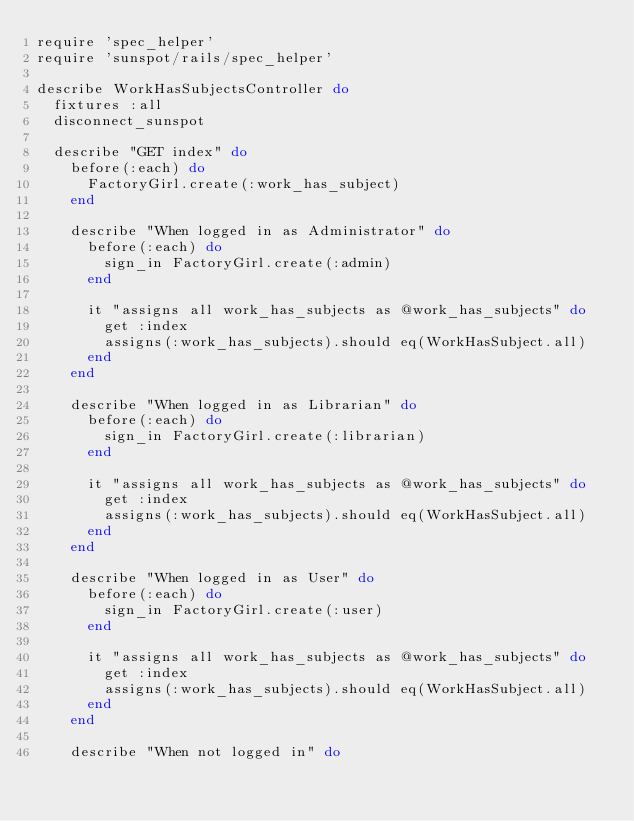<code> <loc_0><loc_0><loc_500><loc_500><_Ruby_>require 'spec_helper'
require 'sunspot/rails/spec_helper'

describe WorkHasSubjectsController do
  fixtures :all
  disconnect_sunspot

  describe "GET index" do
    before(:each) do
      FactoryGirl.create(:work_has_subject)
    end

    describe "When logged in as Administrator" do
      before(:each) do
        sign_in FactoryGirl.create(:admin)
      end

      it "assigns all work_has_subjects as @work_has_subjects" do
        get :index
        assigns(:work_has_subjects).should eq(WorkHasSubject.all)
      end
    end

    describe "When logged in as Librarian" do
      before(:each) do
        sign_in FactoryGirl.create(:librarian)
      end

      it "assigns all work_has_subjects as @work_has_subjects" do
        get :index
        assigns(:work_has_subjects).should eq(WorkHasSubject.all)
      end
    end

    describe "When logged in as User" do
      before(:each) do
        sign_in FactoryGirl.create(:user)
      end

      it "assigns all work_has_subjects as @work_has_subjects" do
        get :index
        assigns(:work_has_subjects).should eq(WorkHasSubject.all)
      end
    end

    describe "When not logged in" do</code> 